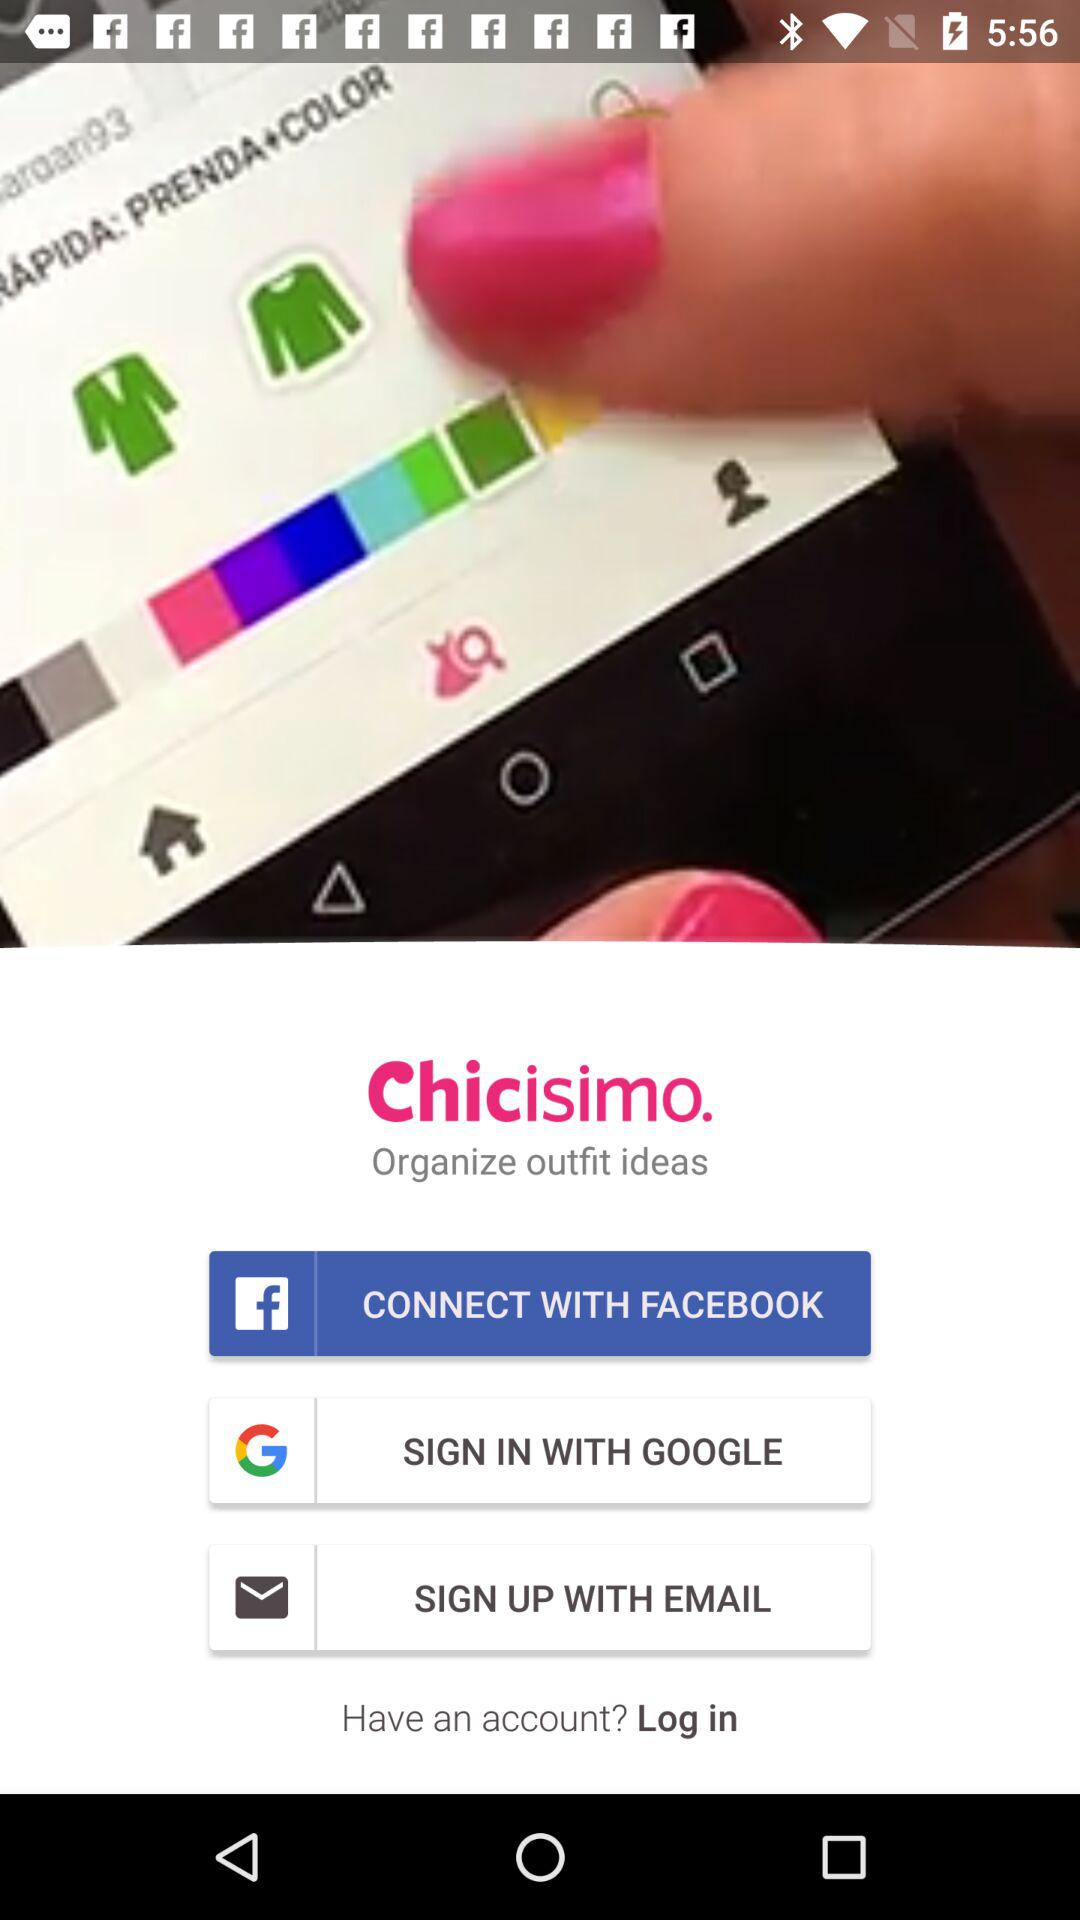What is the name of the application? The name of the application is "Chicisimo". 